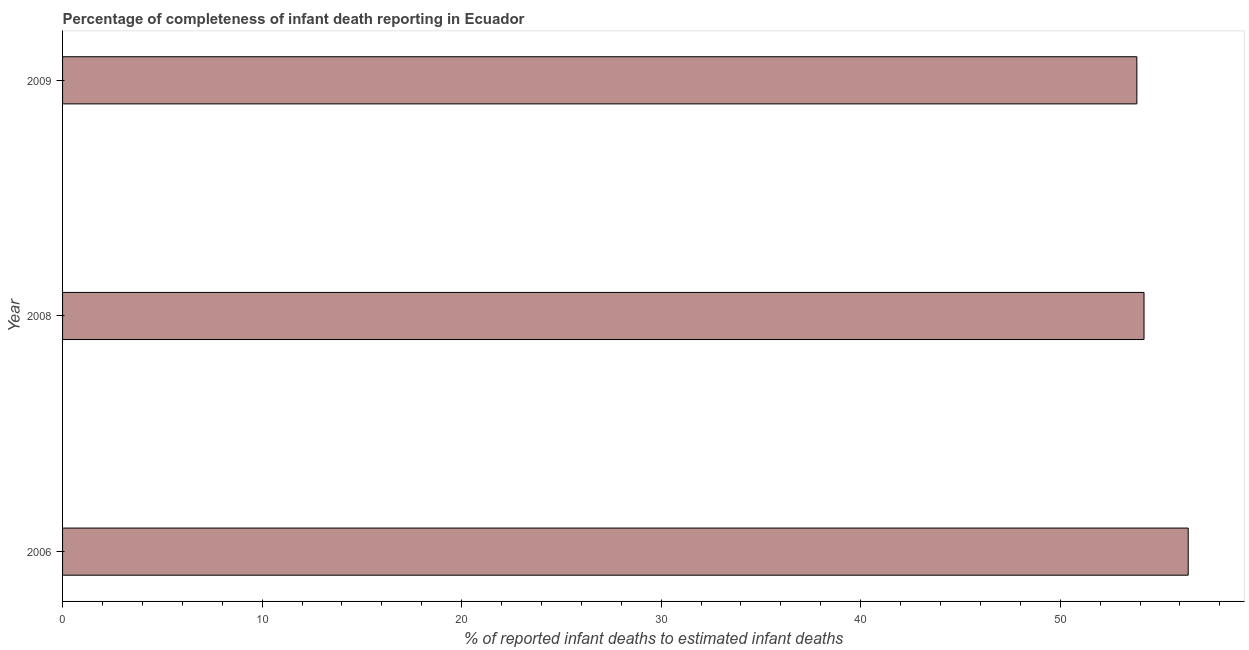What is the title of the graph?
Keep it short and to the point. Percentage of completeness of infant death reporting in Ecuador. What is the label or title of the X-axis?
Offer a terse response. % of reported infant deaths to estimated infant deaths. What is the completeness of infant death reporting in 2009?
Offer a terse response. 53.84. Across all years, what is the maximum completeness of infant death reporting?
Give a very brief answer. 56.42. Across all years, what is the minimum completeness of infant death reporting?
Offer a very short reply. 53.84. In which year was the completeness of infant death reporting maximum?
Your answer should be compact. 2006. In which year was the completeness of infant death reporting minimum?
Your response must be concise. 2009. What is the sum of the completeness of infant death reporting?
Your answer should be very brief. 164.46. What is the difference between the completeness of infant death reporting in 2008 and 2009?
Make the answer very short. 0.36. What is the average completeness of infant death reporting per year?
Ensure brevity in your answer.  54.82. What is the median completeness of infant death reporting?
Your answer should be very brief. 54.2. In how many years, is the completeness of infant death reporting greater than 28 %?
Your answer should be very brief. 3. Do a majority of the years between 2009 and 2006 (inclusive) have completeness of infant death reporting greater than 48 %?
Keep it short and to the point. Yes. What is the ratio of the completeness of infant death reporting in 2006 to that in 2009?
Your answer should be very brief. 1.05. What is the difference between the highest and the second highest completeness of infant death reporting?
Your answer should be compact. 2.21. What is the difference between the highest and the lowest completeness of infant death reporting?
Your response must be concise. 2.57. In how many years, is the completeness of infant death reporting greater than the average completeness of infant death reporting taken over all years?
Give a very brief answer. 1. How many bars are there?
Provide a succinct answer. 3. Are all the bars in the graph horizontal?
Your answer should be very brief. Yes. How many years are there in the graph?
Provide a succinct answer. 3. What is the difference between two consecutive major ticks on the X-axis?
Offer a terse response. 10. Are the values on the major ticks of X-axis written in scientific E-notation?
Offer a very short reply. No. What is the % of reported infant deaths to estimated infant deaths of 2006?
Your answer should be compact. 56.42. What is the % of reported infant deaths to estimated infant deaths in 2008?
Give a very brief answer. 54.2. What is the % of reported infant deaths to estimated infant deaths in 2009?
Your answer should be very brief. 53.84. What is the difference between the % of reported infant deaths to estimated infant deaths in 2006 and 2008?
Offer a very short reply. 2.21. What is the difference between the % of reported infant deaths to estimated infant deaths in 2006 and 2009?
Make the answer very short. 2.57. What is the difference between the % of reported infant deaths to estimated infant deaths in 2008 and 2009?
Your answer should be very brief. 0.36. What is the ratio of the % of reported infant deaths to estimated infant deaths in 2006 to that in 2008?
Your answer should be compact. 1.04. What is the ratio of the % of reported infant deaths to estimated infant deaths in 2006 to that in 2009?
Offer a very short reply. 1.05. What is the ratio of the % of reported infant deaths to estimated infant deaths in 2008 to that in 2009?
Offer a very short reply. 1.01. 